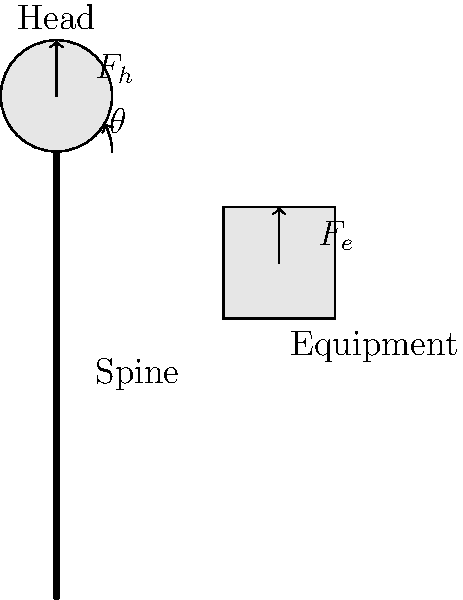In the diagram, a property appraiser is carrying heavy measurement equipment while standing upright. If the weight of the head ($F_h$) is 50N and the weight of the equipment ($F_e$) is 100N, held at an angle of 30° from the vertical, calculate the total compressive force on the spine. To calculate the total compressive force on the spine, we need to consider the vertical components of both the head weight and the equipment weight. Let's break this down step-by-step:

1. The weight of the head ($F_h$) acts directly downward, so its full force contributes to the compressive force on the spine:
   $F_{h,vertical} = 50N$

2. The equipment weight ($F_e$) is at an angle, so we need to find its vertical component:
   $F_{e,vertical} = F_e \times \cos(\theta)$
   $F_{e,vertical} = 100N \times \cos(30°)$
   $F_{e,vertical} = 100N \times \frac{\sqrt{3}}{2} \approx 86.6N$

3. The total compressive force is the sum of these vertical components:
   $F_{total} = F_{h,vertical} + F_{e,vertical}$
   $F_{total} = 50N + 86.6N = 136.6N$

Therefore, the total compressive force on the spine is approximately 136.6N.
Answer: 136.6N 